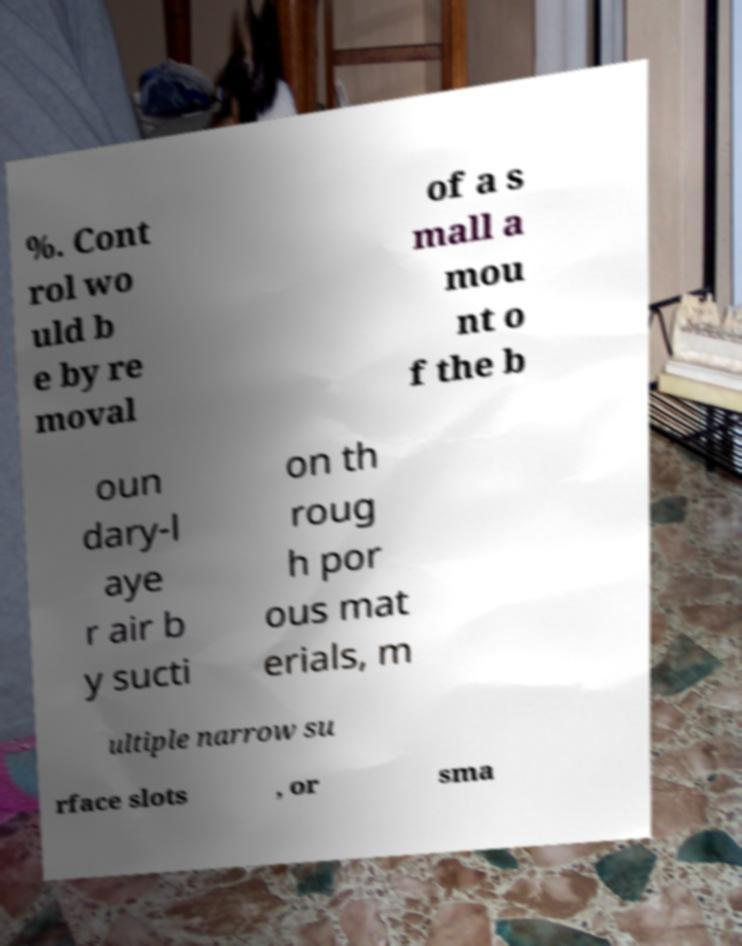Could you assist in decoding the text presented in this image and type it out clearly? %. Cont rol wo uld b e by re moval of a s mall a mou nt o f the b oun dary-l aye r air b y sucti on th roug h por ous mat erials, m ultiple narrow su rface slots , or sma 